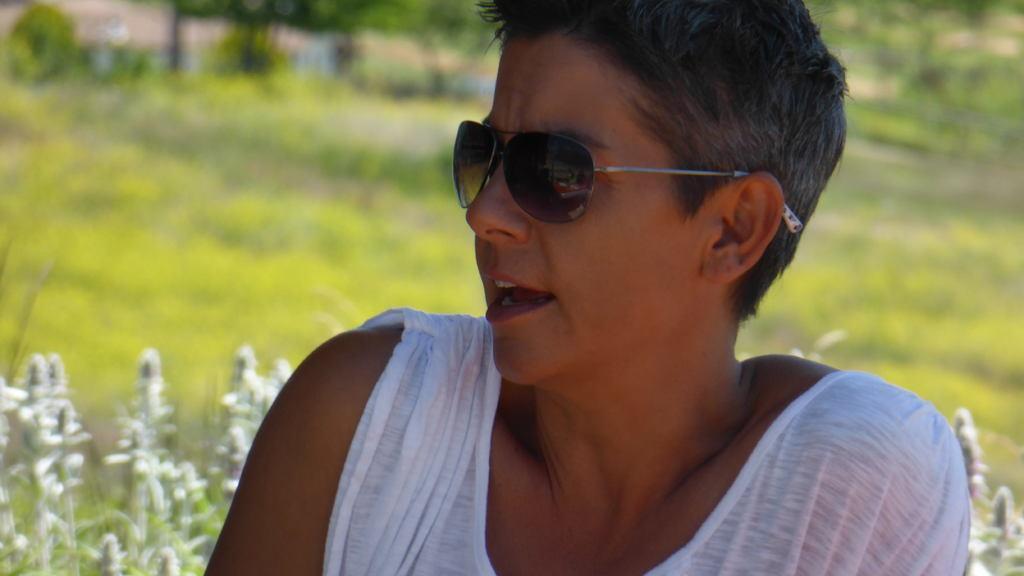How would you summarize this image in a sentence or two? In this image in the foreground there is one person who is wearing goggles, and white dress. And at the bottom there are plants and there is a blurry background. 